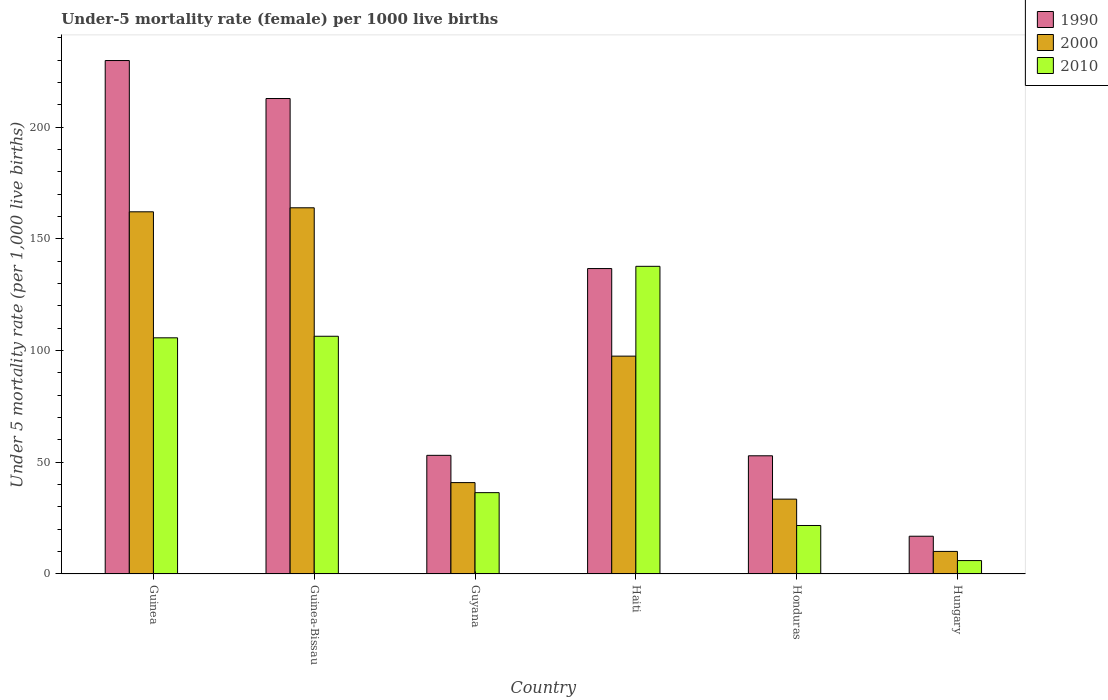How many different coloured bars are there?
Your response must be concise. 3. Are the number of bars per tick equal to the number of legend labels?
Give a very brief answer. Yes. Are the number of bars on each tick of the X-axis equal?
Keep it short and to the point. Yes. What is the label of the 6th group of bars from the left?
Provide a short and direct response. Hungary. What is the under-five mortality rate in 1990 in Honduras?
Provide a succinct answer. 52.9. Across all countries, what is the maximum under-five mortality rate in 1990?
Keep it short and to the point. 229.8. In which country was the under-five mortality rate in 2010 maximum?
Ensure brevity in your answer.  Haiti. In which country was the under-five mortality rate in 2000 minimum?
Provide a short and direct response. Hungary. What is the total under-five mortality rate in 1990 in the graph?
Give a very brief answer. 702.2. What is the difference between the under-five mortality rate in 1990 in Guinea and that in Guyana?
Give a very brief answer. 176.7. What is the difference between the under-five mortality rate in 1990 in Guyana and the under-five mortality rate in 2000 in Guinea?
Provide a short and direct response. -109. What is the average under-five mortality rate in 2010 per country?
Ensure brevity in your answer.  68.98. What is the difference between the under-five mortality rate of/in 2010 and under-five mortality rate of/in 1990 in Guinea-Bissau?
Your answer should be compact. -106.4. What is the ratio of the under-five mortality rate in 2010 in Guyana to that in Haiti?
Keep it short and to the point. 0.26. Is the under-five mortality rate in 2000 in Guinea-Bissau less than that in Hungary?
Give a very brief answer. No. Is the difference between the under-five mortality rate in 2010 in Guyana and Hungary greater than the difference between the under-five mortality rate in 1990 in Guyana and Hungary?
Your response must be concise. No. What is the difference between the highest and the second highest under-five mortality rate in 2010?
Make the answer very short. 31.3. What is the difference between the highest and the lowest under-five mortality rate in 1990?
Your answer should be very brief. 212.9. In how many countries, is the under-five mortality rate in 2010 greater than the average under-five mortality rate in 2010 taken over all countries?
Keep it short and to the point. 3. What does the 1st bar from the left in Guinea represents?
Offer a terse response. 1990. Is it the case that in every country, the sum of the under-five mortality rate in 2010 and under-five mortality rate in 1990 is greater than the under-five mortality rate in 2000?
Ensure brevity in your answer.  Yes. How many bars are there?
Give a very brief answer. 18. Are all the bars in the graph horizontal?
Make the answer very short. No. Where does the legend appear in the graph?
Offer a very short reply. Top right. How are the legend labels stacked?
Your response must be concise. Vertical. What is the title of the graph?
Provide a short and direct response. Under-5 mortality rate (female) per 1000 live births. What is the label or title of the X-axis?
Keep it short and to the point. Country. What is the label or title of the Y-axis?
Make the answer very short. Under 5 mortality rate (per 1,0 live births). What is the Under 5 mortality rate (per 1,000 live births) in 1990 in Guinea?
Offer a terse response. 229.8. What is the Under 5 mortality rate (per 1,000 live births) of 2000 in Guinea?
Your answer should be compact. 162.1. What is the Under 5 mortality rate (per 1,000 live births) in 2010 in Guinea?
Offer a very short reply. 105.7. What is the Under 5 mortality rate (per 1,000 live births) of 1990 in Guinea-Bissau?
Your answer should be compact. 212.8. What is the Under 5 mortality rate (per 1,000 live births) in 2000 in Guinea-Bissau?
Ensure brevity in your answer.  163.9. What is the Under 5 mortality rate (per 1,000 live births) in 2010 in Guinea-Bissau?
Provide a succinct answer. 106.4. What is the Under 5 mortality rate (per 1,000 live births) of 1990 in Guyana?
Give a very brief answer. 53.1. What is the Under 5 mortality rate (per 1,000 live births) in 2000 in Guyana?
Ensure brevity in your answer.  40.9. What is the Under 5 mortality rate (per 1,000 live births) in 2010 in Guyana?
Your response must be concise. 36.4. What is the Under 5 mortality rate (per 1,000 live births) in 1990 in Haiti?
Your answer should be compact. 136.7. What is the Under 5 mortality rate (per 1,000 live births) of 2000 in Haiti?
Make the answer very short. 97.5. What is the Under 5 mortality rate (per 1,000 live births) of 2010 in Haiti?
Your response must be concise. 137.7. What is the Under 5 mortality rate (per 1,000 live births) in 1990 in Honduras?
Provide a succinct answer. 52.9. What is the Under 5 mortality rate (per 1,000 live births) in 2000 in Honduras?
Your answer should be very brief. 33.5. What is the Under 5 mortality rate (per 1,000 live births) of 2010 in Honduras?
Give a very brief answer. 21.7. What is the Under 5 mortality rate (per 1,000 live births) of 2000 in Hungary?
Make the answer very short. 10.1. Across all countries, what is the maximum Under 5 mortality rate (per 1,000 live births) of 1990?
Your response must be concise. 229.8. Across all countries, what is the maximum Under 5 mortality rate (per 1,000 live births) in 2000?
Make the answer very short. 163.9. Across all countries, what is the maximum Under 5 mortality rate (per 1,000 live births) of 2010?
Provide a short and direct response. 137.7. What is the total Under 5 mortality rate (per 1,000 live births) in 1990 in the graph?
Your answer should be very brief. 702.2. What is the total Under 5 mortality rate (per 1,000 live births) of 2000 in the graph?
Your answer should be very brief. 508. What is the total Under 5 mortality rate (per 1,000 live births) of 2010 in the graph?
Offer a very short reply. 413.9. What is the difference between the Under 5 mortality rate (per 1,000 live births) in 1990 in Guinea and that in Guyana?
Make the answer very short. 176.7. What is the difference between the Under 5 mortality rate (per 1,000 live births) of 2000 in Guinea and that in Guyana?
Provide a succinct answer. 121.2. What is the difference between the Under 5 mortality rate (per 1,000 live births) in 2010 in Guinea and that in Guyana?
Provide a succinct answer. 69.3. What is the difference between the Under 5 mortality rate (per 1,000 live births) in 1990 in Guinea and that in Haiti?
Offer a very short reply. 93.1. What is the difference between the Under 5 mortality rate (per 1,000 live births) in 2000 in Guinea and that in Haiti?
Your answer should be very brief. 64.6. What is the difference between the Under 5 mortality rate (per 1,000 live births) in 2010 in Guinea and that in Haiti?
Provide a succinct answer. -32. What is the difference between the Under 5 mortality rate (per 1,000 live births) in 1990 in Guinea and that in Honduras?
Your answer should be compact. 176.9. What is the difference between the Under 5 mortality rate (per 1,000 live births) in 2000 in Guinea and that in Honduras?
Provide a succinct answer. 128.6. What is the difference between the Under 5 mortality rate (per 1,000 live births) of 2010 in Guinea and that in Honduras?
Keep it short and to the point. 84. What is the difference between the Under 5 mortality rate (per 1,000 live births) in 1990 in Guinea and that in Hungary?
Give a very brief answer. 212.9. What is the difference between the Under 5 mortality rate (per 1,000 live births) in 2000 in Guinea and that in Hungary?
Your answer should be compact. 152. What is the difference between the Under 5 mortality rate (per 1,000 live births) in 2010 in Guinea and that in Hungary?
Offer a terse response. 99.7. What is the difference between the Under 5 mortality rate (per 1,000 live births) of 1990 in Guinea-Bissau and that in Guyana?
Give a very brief answer. 159.7. What is the difference between the Under 5 mortality rate (per 1,000 live births) in 2000 in Guinea-Bissau and that in Guyana?
Give a very brief answer. 123. What is the difference between the Under 5 mortality rate (per 1,000 live births) in 2010 in Guinea-Bissau and that in Guyana?
Give a very brief answer. 70. What is the difference between the Under 5 mortality rate (per 1,000 live births) in 1990 in Guinea-Bissau and that in Haiti?
Give a very brief answer. 76.1. What is the difference between the Under 5 mortality rate (per 1,000 live births) of 2000 in Guinea-Bissau and that in Haiti?
Your answer should be very brief. 66.4. What is the difference between the Under 5 mortality rate (per 1,000 live births) of 2010 in Guinea-Bissau and that in Haiti?
Keep it short and to the point. -31.3. What is the difference between the Under 5 mortality rate (per 1,000 live births) in 1990 in Guinea-Bissau and that in Honduras?
Provide a short and direct response. 159.9. What is the difference between the Under 5 mortality rate (per 1,000 live births) of 2000 in Guinea-Bissau and that in Honduras?
Offer a terse response. 130.4. What is the difference between the Under 5 mortality rate (per 1,000 live births) of 2010 in Guinea-Bissau and that in Honduras?
Provide a succinct answer. 84.7. What is the difference between the Under 5 mortality rate (per 1,000 live births) of 1990 in Guinea-Bissau and that in Hungary?
Your response must be concise. 195.9. What is the difference between the Under 5 mortality rate (per 1,000 live births) in 2000 in Guinea-Bissau and that in Hungary?
Make the answer very short. 153.8. What is the difference between the Under 5 mortality rate (per 1,000 live births) in 2010 in Guinea-Bissau and that in Hungary?
Offer a very short reply. 100.4. What is the difference between the Under 5 mortality rate (per 1,000 live births) in 1990 in Guyana and that in Haiti?
Give a very brief answer. -83.6. What is the difference between the Under 5 mortality rate (per 1,000 live births) in 2000 in Guyana and that in Haiti?
Your answer should be very brief. -56.6. What is the difference between the Under 5 mortality rate (per 1,000 live births) in 2010 in Guyana and that in Haiti?
Your answer should be compact. -101.3. What is the difference between the Under 5 mortality rate (per 1,000 live births) of 1990 in Guyana and that in Honduras?
Your answer should be very brief. 0.2. What is the difference between the Under 5 mortality rate (per 1,000 live births) in 2010 in Guyana and that in Honduras?
Provide a short and direct response. 14.7. What is the difference between the Under 5 mortality rate (per 1,000 live births) of 1990 in Guyana and that in Hungary?
Your answer should be very brief. 36.2. What is the difference between the Under 5 mortality rate (per 1,000 live births) in 2000 in Guyana and that in Hungary?
Offer a terse response. 30.8. What is the difference between the Under 5 mortality rate (per 1,000 live births) of 2010 in Guyana and that in Hungary?
Make the answer very short. 30.4. What is the difference between the Under 5 mortality rate (per 1,000 live births) in 1990 in Haiti and that in Honduras?
Your answer should be very brief. 83.8. What is the difference between the Under 5 mortality rate (per 1,000 live births) in 2010 in Haiti and that in Honduras?
Your answer should be compact. 116. What is the difference between the Under 5 mortality rate (per 1,000 live births) in 1990 in Haiti and that in Hungary?
Your answer should be compact. 119.8. What is the difference between the Under 5 mortality rate (per 1,000 live births) of 2000 in Haiti and that in Hungary?
Offer a terse response. 87.4. What is the difference between the Under 5 mortality rate (per 1,000 live births) in 2010 in Haiti and that in Hungary?
Ensure brevity in your answer.  131.7. What is the difference between the Under 5 mortality rate (per 1,000 live births) of 1990 in Honduras and that in Hungary?
Your answer should be very brief. 36. What is the difference between the Under 5 mortality rate (per 1,000 live births) of 2000 in Honduras and that in Hungary?
Give a very brief answer. 23.4. What is the difference between the Under 5 mortality rate (per 1,000 live births) in 1990 in Guinea and the Under 5 mortality rate (per 1,000 live births) in 2000 in Guinea-Bissau?
Offer a very short reply. 65.9. What is the difference between the Under 5 mortality rate (per 1,000 live births) of 1990 in Guinea and the Under 5 mortality rate (per 1,000 live births) of 2010 in Guinea-Bissau?
Give a very brief answer. 123.4. What is the difference between the Under 5 mortality rate (per 1,000 live births) in 2000 in Guinea and the Under 5 mortality rate (per 1,000 live births) in 2010 in Guinea-Bissau?
Make the answer very short. 55.7. What is the difference between the Under 5 mortality rate (per 1,000 live births) in 1990 in Guinea and the Under 5 mortality rate (per 1,000 live births) in 2000 in Guyana?
Your answer should be compact. 188.9. What is the difference between the Under 5 mortality rate (per 1,000 live births) of 1990 in Guinea and the Under 5 mortality rate (per 1,000 live births) of 2010 in Guyana?
Provide a short and direct response. 193.4. What is the difference between the Under 5 mortality rate (per 1,000 live births) in 2000 in Guinea and the Under 5 mortality rate (per 1,000 live births) in 2010 in Guyana?
Give a very brief answer. 125.7. What is the difference between the Under 5 mortality rate (per 1,000 live births) in 1990 in Guinea and the Under 5 mortality rate (per 1,000 live births) in 2000 in Haiti?
Your answer should be compact. 132.3. What is the difference between the Under 5 mortality rate (per 1,000 live births) in 1990 in Guinea and the Under 5 mortality rate (per 1,000 live births) in 2010 in Haiti?
Your response must be concise. 92.1. What is the difference between the Under 5 mortality rate (per 1,000 live births) in 2000 in Guinea and the Under 5 mortality rate (per 1,000 live births) in 2010 in Haiti?
Your answer should be very brief. 24.4. What is the difference between the Under 5 mortality rate (per 1,000 live births) in 1990 in Guinea and the Under 5 mortality rate (per 1,000 live births) in 2000 in Honduras?
Give a very brief answer. 196.3. What is the difference between the Under 5 mortality rate (per 1,000 live births) in 1990 in Guinea and the Under 5 mortality rate (per 1,000 live births) in 2010 in Honduras?
Provide a short and direct response. 208.1. What is the difference between the Under 5 mortality rate (per 1,000 live births) in 2000 in Guinea and the Under 5 mortality rate (per 1,000 live births) in 2010 in Honduras?
Your answer should be very brief. 140.4. What is the difference between the Under 5 mortality rate (per 1,000 live births) of 1990 in Guinea and the Under 5 mortality rate (per 1,000 live births) of 2000 in Hungary?
Ensure brevity in your answer.  219.7. What is the difference between the Under 5 mortality rate (per 1,000 live births) of 1990 in Guinea and the Under 5 mortality rate (per 1,000 live births) of 2010 in Hungary?
Offer a terse response. 223.8. What is the difference between the Under 5 mortality rate (per 1,000 live births) of 2000 in Guinea and the Under 5 mortality rate (per 1,000 live births) of 2010 in Hungary?
Your response must be concise. 156.1. What is the difference between the Under 5 mortality rate (per 1,000 live births) of 1990 in Guinea-Bissau and the Under 5 mortality rate (per 1,000 live births) of 2000 in Guyana?
Keep it short and to the point. 171.9. What is the difference between the Under 5 mortality rate (per 1,000 live births) of 1990 in Guinea-Bissau and the Under 5 mortality rate (per 1,000 live births) of 2010 in Guyana?
Keep it short and to the point. 176.4. What is the difference between the Under 5 mortality rate (per 1,000 live births) of 2000 in Guinea-Bissau and the Under 5 mortality rate (per 1,000 live births) of 2010 in Guyana?
Provide a short and direct response. 127.5. What is the difference between the Under 5 mortality rate (per 1,000 live births) of 1990 in Guinea-Bissau and the Under 5 mortality rate (per 1,000 live births) of 2000 in Haiti?
Your answer should be compact. 115.3. What is the difference between the Under 5 mortality rate (per 1,000 live births) in 1990 in Guinea-Bissau and the Under 5 mortality rate (per 1,000 live births) in 2010 in Haiti?
Your answer should be very brief. 75.1. What is the difference between the Under 5 mortality rate (per 1,000 live births) of 2000 in Guinea-Bissau and the Under 5 mortality rate (per 1,000 live births) of 2010 in Haiti?
Keep it short and to the point. 26.2. What is the difference between the Under 5 mortality rate (per 1,000 live births) of 1990 in Guinea-Bissau and the Under 5 mortality rate (per 1,000 live births) of 2000 in Honduras?
Keep it short and to the point. 179.3. What is the difference between the Under 5 mortality rate (per 1,000 live births) of 1990 in Guinea-Bissau and the Under 5 mortality rate (per 1,000 live births) of 2010 in Honduras?
Your answer should be compact. 191.1. What is the difference between the Under 5 mortality rate (per 1,000 live births) of 2000 in Guinea-Bissau and the Under 5 mortality rate (per 1,000 live births) of 2010 in Honduras?
Offer a very short reply. 142.2. What is the difference between the Under 5 mortality rate (per 1,000 live births) in 1990 in Guinea-Bissau and the Under 5 mortality rate (per 1,000 live births) in 2000 in Hungary?
Give a very brief answer. 202.7. What is the difference between the Under 5 mortality rate (per 1,000 live births) in 1990 in Guinea-Bissau and the Under 5 mortality rate (per 1,000 live births) in 2010 in Hungary?
Your answer should be very brief. 206.8. What is the difference between the Under 5 mortality rate (per 1,000 live births) in 2000 in Guinea-Bissau and the Under 5 mortality rate (per 1,000 live births) in 2010 in Hungary?
Give a very brief answer. 157.9. What is the difference between the Under 5 mortality rate (per 1,000 live births) in 1990 in Guyana and the Under 5 mortality rate (per 1,000 live births) in 2000 in Haiti?
Keep it short and to the point. -44.4. What is the difference between the Under 5 mortality rate (per 1,000 live births) of 1990 in Guyana and the Under 5 mortality rate (per 1,000 live births) of 2010 in Haiti?
Your answer should be compact. -84.6. What is the difference between the Under 5 mortality rate (per 1,000 live births) in 2000 in Guyana and the Under 5 mortality rate (per 1,000 live births) in 2010 in Haiti?
Provide a succinct answer. -96.8. What is the difference between the Under 5 mortality rate (per 1,000 live births) of 1990 in Guyana and the Under 5 mortality rate (per 1,000 live births) of 2000 in Honduras?
Give a very brief answer. 19.6. What is the difference between the Under 5 mortality rate (per 1,000 live births) in 1990 in Guyana and the Under 5 mortality rate (per 1,000 live births) in 2010 in Honduras?
Your answer should be very brief. 31.4. What is the difference between the Under 5 mortality rate (per 1,000 live births) in 1990 in Guyana and the Under 5 mortality rate (per 1,000 live births) in 2000 in Hungary?
Your response must be concise. 43. What is the difference between the Under 5 mortality rate (per 1,000 live births) of 1990 in Guyana and the Under 5 mortality rate (per 1,000 live births) of 2010 in Hungary?
Your answer should be very brief. 47.1. What is the difference between the Under 5 mortality rate (per 1,000 live births) of 2000 in Guyana and the Under 5 mortality rate (per 1,000 live births) of 2010 in Hungary?
Offer a terse response. 34.9. What is the difference between the Under 5 mortality rate (per 1,000 live births) of 1990 in Haiti and the Under 5 mortality rate (per 1,000 live births) of 2000 in Honduras?
Ensure brevity in your answer.  103.2. What is the difference between the Under 5 mortality rate (per 1,000 live births) in 1990 in Haiti and the Under 5 mortality rate (per 1,000 live births) in 2010 in Honduras?
Give a very brief answer. 115. What is the difference between the Under 5 mortality rate (per 1,000 live births) in 2000 in Haiti and the Under 5 mortality rate (per 1,000 live births) in 2010 in Honduras?
Give a very brief answer. 75.8. What is the difference between the Under 5 mortality rate (per 1,000 live births) of 1990 in Haiti and the Under 5 mortality rate (per 1,000 live births) of 2000 in Hungary?
Provide a succinct answer. 126.6. What is the difference between the Under 5 mortality rate (per 1,000 live births) of 1990 in Haiti and the Under 5 mortality rate (per 1,000 live births) of 2010 in Hungary?
Your answer should be very brief. 130.7. What is the difference between the Under 5 mortality rate (per 1,000 live births) in 2000 in Haiti and the Under 5 mortality rate (per 1,000 live births) in 2010 in Hungary?
Your answer should be compact. 91.5. What is the difference between the Under 5 mortality rate (per 1,000 live births) of 1990 in Honduras and the Under 5 mortality rate (per 1,000 live births) of 2000 in Hungary?
Give a very brief answer. 42.8. What is the difference between the Under 5 mortality rate (per 1,000 live births) of 1990 in Honduras and the Under 5 mortality rate (per 1,000 live births) of 2010 in Hungary?
Your answer should be very brief. 46.9. What is the difference between the Under 5 mortality rate (per 1,000 live births) of 2000 in Honduras and the Under 5 mortality rate (per 1,000 live births) of 2010 in Hungary?
Provide a short and direct response. 27.5. What is the average Under 5 mortality rate (per 1,000 live births) in 1990 per country?
Provide a succinct answer. 117.03. What is the average Under 5 mortality rate (per 1,000 live births) in 2000 per country?
Ensure brevity in your answer.  84.67. What is the average Under 5 mortality rate (per 1,000 live births) in 2010 per country?
Your answer should be very brief. 68.98. What is the difference between the Under 5 mortality rate (per 1,000 live births) of 1990 and Under 5 mortality rate (per 1,000 live births) of 2000 in Guinea?
Your answer should be compact. 67.7. What is the difference between the Under 5 mortality rate (per 1,000 live births) of 1990 and Under 5 mortality rate (per 1,000 live births) of 2010 in Guinea?
Make the answer very short. 124.1. What is the difference between the Under 5 mortality rate (per 1,000 live births) in 2000 and Under 5 mortality rate (per 1,000 live births) in 2010 in Guinea?
Offer a very short reply. 56.4. What is the difference between the Under 5 mortality rate (per 1,000 live births) of 1990 and Under 5 mortality rate (per 1,000 live births) of 2000 in Guinea-Bissau?
Keep it short and to the point. 48.9. What is the difference between the Under 5 mortality rate (per 1,000 live births) of 1990 and Under 5 mortality rate (per 1,000 live births) of 2010 in Guinea-Bissau?
Your answer should be compact. 106.4. What is the difference between the Under 5 mortality rate (per 1,000 live births) of 2000 and Under 5 mortality rate (per 1,000 live births) of 2010 in Guinea-Bissau?
Provide a succinct answer. 57.5. What is the difference between the Under 5 mortality rate (per 1,000 live births) in 1990 and Under 5 mortality rate (per 1,000 live births) in 2000 in Guyana?
Your answer should be very brief. 12.2. What is the difference between the Under 5 mortality rate (per 1,000 live births) in 2000 and Under 5 mortality rate (per 1,000 live births) in 2010 in Guyana?
Your answer should be very brief. 4.5. What is the difference between the Under 5 mortality rate (per 1,000 live births) in 1990 and Under 5 mortality rate (per 1,000 live births) in 2000 in Haiti?
Make the answer very short. 39.2. What is the difference between the Under 5 mortality rate (per 1,000 live births) in 1990 and Under 5 mortality rate (per 1,000 live births) in 2010 in Haiti?
Your answer should be very brief. -1. What is the difference between the Under 5 mortality rate (per 1,000 live births) in 2000 and Under 5 mortality rate (per 1,000 live births) in 2010 in Haiti?
Provide a short and direct response. -40.2. What is the difference between the Under 5 mortality rate (per 1,000 live births) in 1990 and Under 5 mortality rate (per 1,000 live births) in 2010 in Honduras?
Provide a succinct answer. 31.2. What is the difference between the Under 5 mortality rate (per 1,000 live births) in 1990 and Under 5 mortality rate (per 1,000 live births) in 2000 in Hungary?
Keep it short and to the point. 6.8. What is the difference between the Under 5 mortality rate (per 1,000 live births) of 2000 and Under 5 mortality rate (per 1,000 live births) of 2010 in Hungary?
Your answer should be very brief. 4.1. What is the ratio of the Under 5 mortality rate (per 1,000 live births) of 1990 in Guinea to that in Guinea-Bissau?
Provide a succinct answer. 1.08. What is the ratio of the Under 5 mortality rate (per 1,000 live births) of 2000 in Guinea to that in Guinea-Bissau?
Your response must be concise. 0.99. What is the ratio of the Under 5 mortality rate (per 1,000 live births) in 2010 in Guinea to that in Guinea-Bissau?
Make the answer very short. 0.99. What is the ratio of the Under 5 mortality rate (per 1,000 live births) in 1990 in Guinea to that in Guyana?
Offer a terse response. 4.33. What is the ratio of the Under 5 mortality rate (per 1,000 live births) in 2000 in Guinea to that in Guyana?
Offer a very short reply. 3.96. What is the ratio of the Under 5 mortality rate (per 1,000 live births) of 2010 in Guinea to that in Guyana?
Provide a short and direct response. 2.9. What is the ratio of the Under 5 mortality rate (per 1,000 live births) in 1990 in Guinea to that in Haiti?
Provide a short and direct response. 1.68. What is the ratio of the Under 5 mortality rate (per 1,000 live births) in 2000 in Guinea to that in Haiti?
Offer a terse response. 1.66. What is the ratio of the Under 5 mortality rate (per 1,000 live births) in 2010 in Guinea to that in Haiti?
Keep it short and to the point. 0.77. What is the ratio of the Under 5 mortality rate (per 1,000 live births) of 1990 in Guinea to that in Honduras?
Provide a short and direct response. 4.34. What is the ratio of the Under 5 mortality rate (per 1,000 live births) of 2000 in Guinea to that in Honduras?
Make the answer very short. 4.84. What is the ratio of the Under 5 mortality rate (per 1,000 live births) of 2010 in Guinea to that in Honduras?
Ensure brevity in your answer.  4.87. What is the ratio of the Under 5 mortality rate (per 1,000 live births) of 1990 in Guinea to that in Hungary?
Offer a very short reply. 13.6. What is the ratio of the Under 5 mortality rate (per 1,000 live births) in 2000 in Guinea to that in Hungary?
Offer a terse response. 16.05. What is the ratio of the Under 5 mortality rate (per 1,000 live births) of 2010 in Guinea to that in Hungary?
Your answer should be compact. 17.62. What is the ratio of the Under 5 mortality rate (per 1,000 live births) in 1990 in Guinea-Bissau to that in Guyana?
Your answer should be compact. 4.01. What is the ratio of the Under 5 mortality rate (per 1,000 live births) in 2000 in Guinea-Bissau to that in Guyana?
Provide a succinct answer. 4.01. What is the ratio of the Under 5 mortality rate (per 1,000 live births) of 2010 in Guinea-Bissau to that in Guyana?
Provide a short and direct response. 2.92. What is the ratio of the Under 5 mortality rate (per 1,000 live births) of 1990 in Guinea-Bissau to that in Haiti?
Provide a succinct answer. 1.56. What is the ratio of the Under 5 mortality rate (per 1,000 live births) of 2000 in Guinea-Bissau to that in Haiti?
Your answer should be compact. 1.68. What is the ratio of the Under 5 mortality rate (per 1,000 live births) of 2010 in Guinea-Bissau to that in Haiti?
Ensure brevity in your answer.  0.77. What is the ratio of the Under 5 mortality rate (per 1,000 live births) of 1990 in Guinea-Bissau to that in Honduras?
Give a very brief answer. 4.02. What is the ratio of the Under 5 mortality rate (per 1,000 live births) in 2000 in Guinea-Bissau to that in Honduras?
Provide a succinct answer. 4.89. What is the ratio of the Under 5 mortality rate (per 1,000 live births) in 2010 in Guinea-Bissau to that in Honduras?
Provide a short and direct response. 4.9. What is the ratio of the Under 5 mortality rate (per 1,000 live births) of 1990 in Guinea-Bissau to that in Hungary?
Your answer should be very brief. 12.59. What is the ratio of the Under 5 mortality rate (per 1,000 live births) of 2000 in Guinea-Bissau to that in Hungary?
Offer a terse response. 16.23. What is the ratio of the Under 5 mortality rate (per 1,000 live births) in 2010 in Guinea-Bissau to that in Hungary?
Give a very brief answer. 17.73. What is the ratio of the Under 5 mortality rate (per 1,000 live births) in 1990 in Guyana to that in Haiti?
Offer a very short reply. 0.39. What is the ratio of the Under 5 mortality rate (per 1,000 live births) of 2000 in Guyana to that in Haiti?
Make the answer very short. 0.42. What is the ratio of the Under 5 mortality rate (per 1,000 live births) of 2010 in Guyana to that in Haiti?
Provide a succinct answer. 0.26. What is the ratio of the Under 5 mortality rate (per 1,000 live births) in 2000 in Guyana to that in Honduras?
Your answer should be very brief. 1.22. What is the ratio of the Under 5 mortality rate (per 1,000 live births) in 2010 in Guyana to that in Honduras?
Offer a very short reply. 1.68. What is the ratio of the Under 5 mortality rate (per 1,000 live births) of 1990 in Guyana to that in Hungary?
Make the answer very short. 3.14. What is the ratio of the Under 5 mortality rate (per 1,000 live births) of 2000 in Guyana to that in Hungary?
Your response must be concise. 4.05. What is the ratio of the Under 5 mortality rate (per 1,000 live births) in 2010 in Guyana to that in Hungary?
Your answer should be very brief. 6.07. What is the ratio of the Under 5 mortality rate (per 1,000 live births) in 1990 in Haiti to that in Honduras?
Offer a terse response. 2.58. What is the ratio of the Under 5 mortality rate (per 1,000 live births) of 2000 in Haiti to that in Honduras?
Your answer should be compact. 2.91. What is the ratio of the Under 5 mortality rate (per 1,000 live births) of 2010 in Haiti to that in Honduras?
Provide a short and direct response. 6.35. What is the ratio of the Under 5 mortality rate (per 1,000 live births) of 1990 in Haiti to that in Hungary?
Provide a short and direct response. 8.09. What is the ratio of the Under 5 mortality rate (per 1,000 live births) of 2000 in Haiti to that in Hungary?
Provide a short and direct response. 9.65. What is the ratio of the Under 5 mortality rate (per 1,000 live births) of 2010 in Haiti to that in Hungary?
Keep it short and to the point. 22.95. What is the ratio of the Under 5 mortality rate (per 1,000 live births) of 1990 in Honduras to that in Hungary?
Offer a very short reply. 3.13. What is the ratio of the Under 5 mortality rate (per 1,000 live births) of 2000 in Honduras to that in Hungary?
Your answer should be very brief. 3.32. What is the ratio of the Under 5 mortality rate (per 1,000 live births) of 2010 in Honduras to that in Hungary?
Provide a succinct answer. 3.62. What is the difference between the highest and the second highest Under 5 mortality rate (per 1,000 live births) in 2000?
Your answer should be very brief. 1.8. What is the difference between the highest and the second highest Under 5 mortality rate (per 1,000 live births) in 2010?
Your answer should be compact. 31.3. What is the difference between the highest and the lowest Under 5 mortality rate (per 1,000 live births) in 1990?
Offer a very short reply. 212.9. What is the difference between the highest and the lowest Under 5 mortality rate (per 1,000 live births) of 2000?
Give a very brief answer. 153.8. What is the difference between the highest and the lowest Under 5 mortality rate (per 1,000 live births) in 2010?
Your answer should be compact. 131.7. 